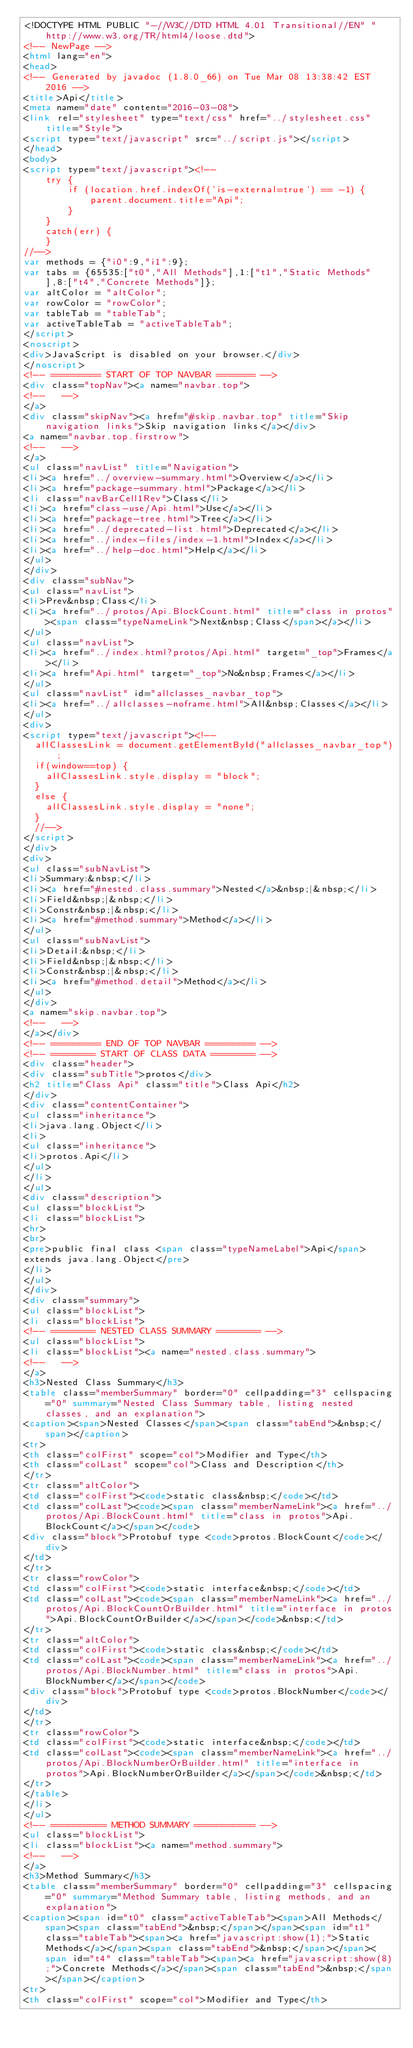Convert code to text. <code><loc_0><loc_0><loc_500><loc_500><_HTML_><!DOCTYPE HTML PUBLIC "-//W3C//DTD HTML 4.01 Transitional//EN" "http://www.w3.org/TR/html4/loose.dtd">
<!-- NewPage -->
<html lang="en">
<head>
<!-- Generated by javadoc (1.8.0_66) on Tue Mar 08 13:38:42 EST 2016 -->
<title>Api</title>
<meta name="date" content="2016-03-08">
<link rel="stylesheet" type="text/css" href="../stylesheet.css" title="Style">
<script type="text/javascript" src="../script.js"></script>
</head>
<body>
<script type="text/javascript"><!--
    try {
        if (location.href.indexOf('is-external=true') == -1) {
            parent.document.title="Api";
        }
    }
    catch(err) {
    }
//-->
var methods = {"i0":9,"i1":9};
var tabs = {65535:["t0","All Methods"],1:["t1","Static Methods"],8:["t4","Concrete Methods"]};
var altColor = "altColor";
var rowColor = "rowColor";
var tableTab = "tableTab";
var activeTableTab = "activeTableTab";
</script>
<noscript>
<div>JavaScript is disabled on your browser.</div>
</noscript>
<!-- ========= START OF TOP NAVBAR ======= -->
<div class="topNav"><a name="navbar.top">
<!--   -->
</a>
<div class="skipNav"><a href="#skip.navbar.top" title="Skip navigation links">Skip navigation links</a></div>
<a name="navbar.top.firstrow">
<!--   -->
</a>
<ul class="navList" title="Navigation">
<li><a href="../overview-summary.html">Overview</a></li>
<li><a href="package-summary.html">Package</a></li>
<li class="navBarCell1Rev">Class</li>
<li><a href="class-use/Api.html">Use</a></li>
<li><a href="package-tree.html">Tree</a></li>
<li><a href="../deprecated-list.html">Deprecated</a></li>
<li><a href="../index-files/index-1.html">Index</a></li>
<li><a href="../help-doc.html">Help</a></li>
</ul>
</div>
<div class="subNav">
<ul class="navList">
<li>Prev&nbsp;Class</li>
<li><a href="../protos/Api.BlockCount.html" title="class in protos"><span class="typeNameLink">Next&nbsp;Class</span></a></li>
</ul>
<ul class="navList">
<li><a href="../index.html?protos/Api.html" target="_top">Frames</a></li>
<li><a href="Api.html" target="_top">No&nbsp;Frames</a></li>
</ul>
<ul class="navList" id="allclasses_navbar_top">
<li><a href="../allclasses-noframe.html">All&nbsp;Classes</a></li>
</ul>
<div>
<script type="text/javascript"><!--
  allClassesLink = document.getElementById("allclasses_navbar_top");
  if(window==top) {
    allClassesLink.style.display = "block";
  }
  else {
    allClassesLink.style.display = "none";
  }
  //-->
</script>
</div>
<div>
<ul class="subNavList">
<li>Summary:&nbsp;</li>
<li><a href="#nested.class.summary">Nested</a>&nbsp;|&nbsp;</li>
<li>Field&nbsp;|&nbsp;</li>
<li>Constr&nbsp;|&nbsp;</li>
<li><a href="#method.summary">Method</a></li>
</ul>
<ul class="subNavList">
<li>Detail:&nbsp;</li>
<li>Field&nbsp;|&nbsp;</li>
<li>Constr&nbsp;|&nbsp;</li>
<li><a href="#method.detail">Method</a></li>
</ul>
</div>
<a name="skip.navbar.top">
<!--   -->
</a></div>
<!-- ========= END OF TOP NAVBAR ========= -->
<!-- ======== START OF CLASS DATA ======== -->
<div class="header">
<div class="subTitle">protos</div>
<h2 title="Class Api" class="title">Class Api</h2>
</div>
<div class="contentContainer">
<ul class="inheritance">
<li>java.lang.Object</li>
<li>
<ul class="inheritance">
<li>protos.Api</li>
</ul>
</li>
</ul>
<div class="description">
<ul class="blockList">
<li class="blockList">
<hr>
<br>
<pre>public final class <span class="typeNameLabel">Api</span>
extends java.lang.Object</pre>
</li>
</ul>
</div>
<div class="summary">
<ul class="blockList">
<li class="blockList">
<!-- ======== NESTED CLASS SUMMARY ======== -->
<ul class="blockList">
<li class="blockList"><a name="nested.class.summary">
<!--   -->
</a>
<h3>Nested Class Summary</h3>
<table class="memberSummary" border="0" cellpadding="3" cellspacing="0" summary="Nested Class Summary table, listing nested classes, and an explanation">
<caption><span>Nested Classes</span><span class="tabEnd">&nbsp;</span></caption>
<tr>
<th class="colFirst" scope="col">Modifier and Type</th>
<th class="colLast" scope="col">Class and Description</th>
</tr>
<tr class="altColor">
<td class="colFirst"><code>static class&nbsp;</code></td>
<td class="colLast"><code><span class="memberNameLink"><a href="../protos/Api.BlockCount.html" title="class in protos">Api.BlockCount</a></span></code>
<div class="block">Protobuf type <code>protos.BlockCount</code></div>
</td>
</tr>
<tr class="rowColor">
<td class="colFirst"><code>static interface&nbsp;</code></td>
<td class="colLast"><code><span class="memberNameLink"><a href="../protos/Api.BlockCountOrBuilder.html" title="interface in protos">Api.BlockCountOrBuilder</a></span></code>&nbsp;</td>
</tr>
<tr class="altColor">
<td class="colFirst"><code>static class&nbsp;</code></td>
<td class="colLast"><code><span class="memberNameLink"><a href="../protos/Api.BlockNumber.html" title="class in protos">Api.BlockNumber</a></span></code>
<div class="block">Protobuf type <code>protos.BlockNumber</code></div>
</td>
</tr>
<tr class="rowColor">
<td class="colFirst"><code>static interface&nbsp;</code></td>
<td class="colLast"><code><span class="memberNameLink"><a href="../protos/Api.BlockNumberOrBuilder.html" title="interface in protos">Api.BlockNumberOrBuilder</a></span></code>&nbsp;</td>
</tr>
</table>
</li>
</ul>
<!-- ========== METHOD SUMMARY =========== -->
<ul class="blockList">
<li class="blockList"><a name="method.summary">
<!--   -->
</a>
<h3>Method Summary</h3>
<table class="memberSummary" border="0" cellpadding="3" cellspacing="0" summary="Method Summary table, listing methods, and an explanation">
<caption><span id="t0" class="activeTableTab"><span>All Methods</span><span class="tabEnd">&nbsp;</span></span><span id="t1" class="tableTab"><span><a href="javascript:show(1);">Static Methods</a></span><span class="tabEnd">&nbsp;</span></span><span id="t4" class="tableTab"><span><a href="javascript:show(8);">Concrete Methods</a></span><span class="tabEnd">&nbsp;</span></span></caption>
<tr>
<th class="colFirst" scope="col">Modifier and Type</th></code> 